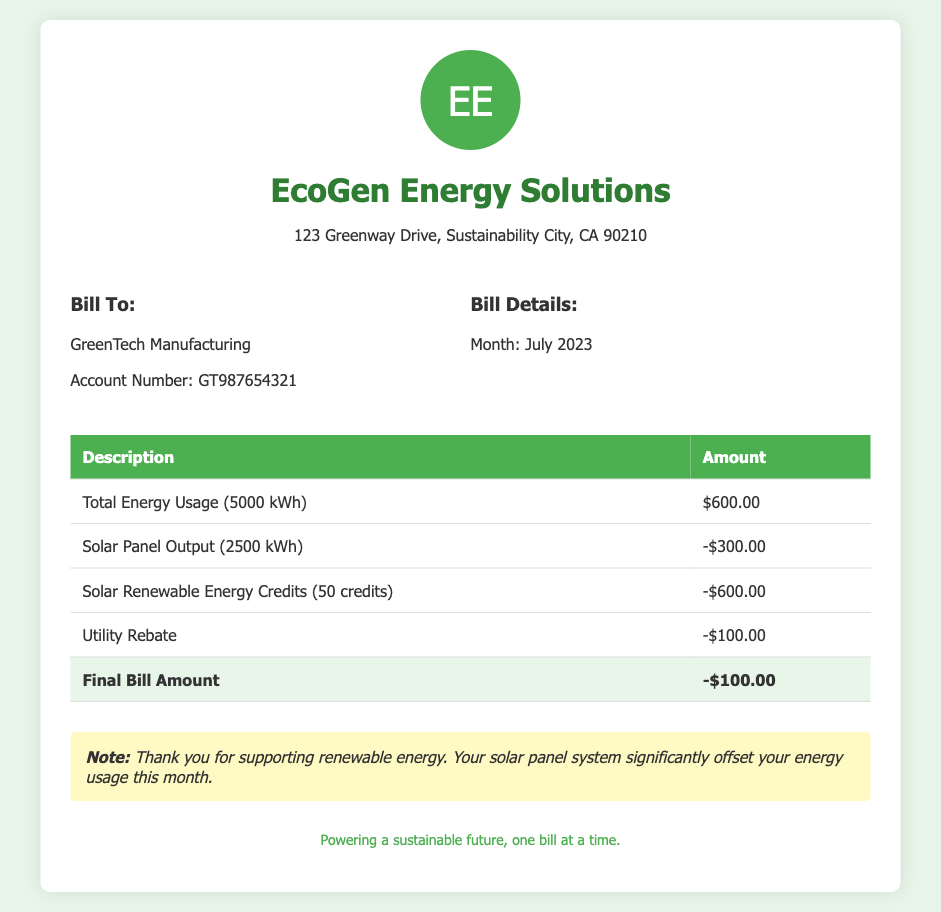What is the total energy usage? The total energy usage listed in the document is 5000 kWh.
Answer: 5000 kWh How much is the solar panel output credited? The credit for the solar panel output that offsets the bill is represented as -$300.00.
Answer: -$300.00 What is the account number for GreenTech Manufacturing? The account number provided in the document for GreenTech Manufacturing is GT987654321.
Answer: GT987654321 How many Solar Renewable Energy Credits were earned? The document states that 50 Solar Renewable Energy Credits were earned.
Answer: 50 credits What is the final bill amount? The final bill amount calculated after deductions is -$100.00.
Answer: -$100.00 What month is this bill for? The bill clearly states the month for which it is issued as July 2023.
Answer: July 2023 What is the utility rebate amount? The utility rebate amount mentioned in the document is -$100.00.
Answer: -$100.00 What is the solar panel output in kWh? According to the document, the solar panel output is 2500 kWh.
Answer: 2500 kWh What message is included in the notes section? The note included expresses gratitude for supporting renewable energy and mentions the impact of the solar panel system.
Answer: Thank you for supporting renewable energy. Your solar panel system significantly offset your energy usage this month 